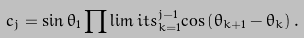<formula> <loc_0><loc_0><loc_500><loc_500>c _ { j } = \sin \theta _ { 1 } \prod \lim i t s _ { k = 1 } ^ { j - 1 } { \cos \left ( { \theta _ { k + 1 } - \theta _ { k } } \right ) } \, .</formula> 